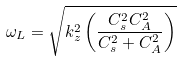<formula> <loc_0><loc_0><loc_500><loc_500>\omega _ { L } = { \sqrt { k _ { z } ^ { 2 } \left ( { \frac { C _ { s } ^ { 2 } C _ { A } ^ { 2 } } { C _ { s } ^ { 2 } + C _ { A } ^ { 2 } } } \right ) } }</formula> 